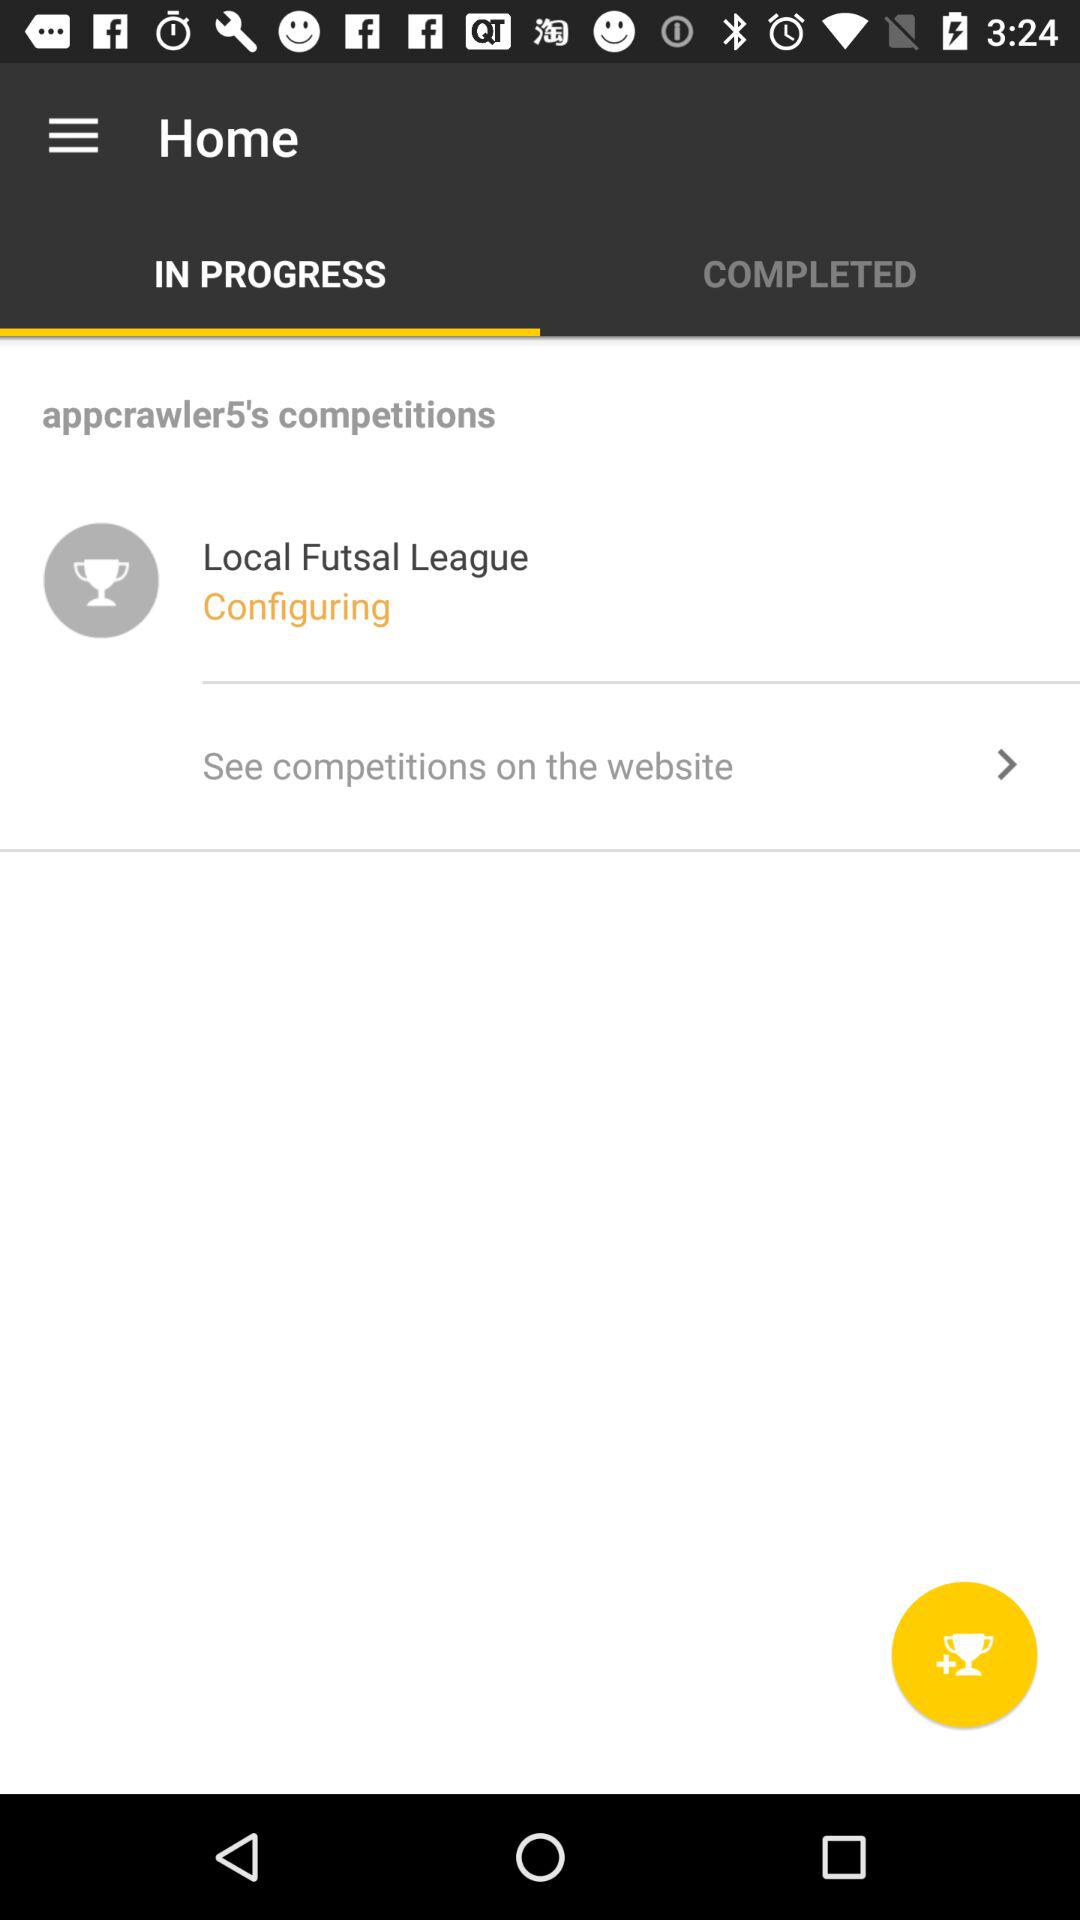Which tab is selected? The selected tab is "IN PROGRESS". 